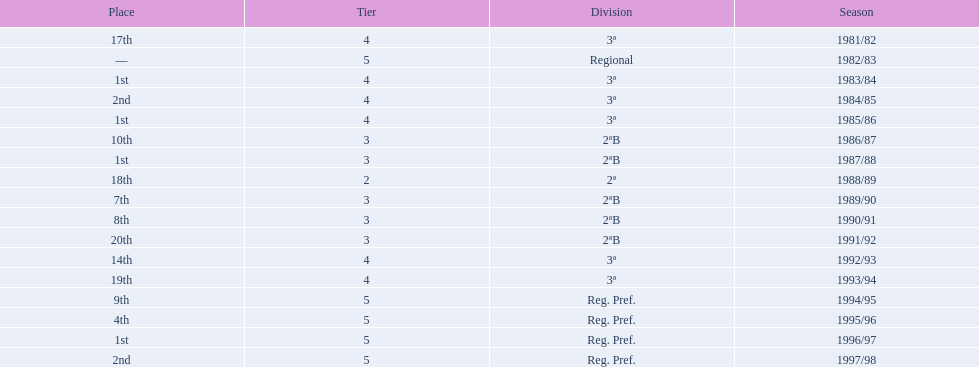In what years did the team finish 17th or worse? 1981/82, 1988/89, 1991/92, 1993/94. Of those, in which year the team finish worse? 1991/92. 